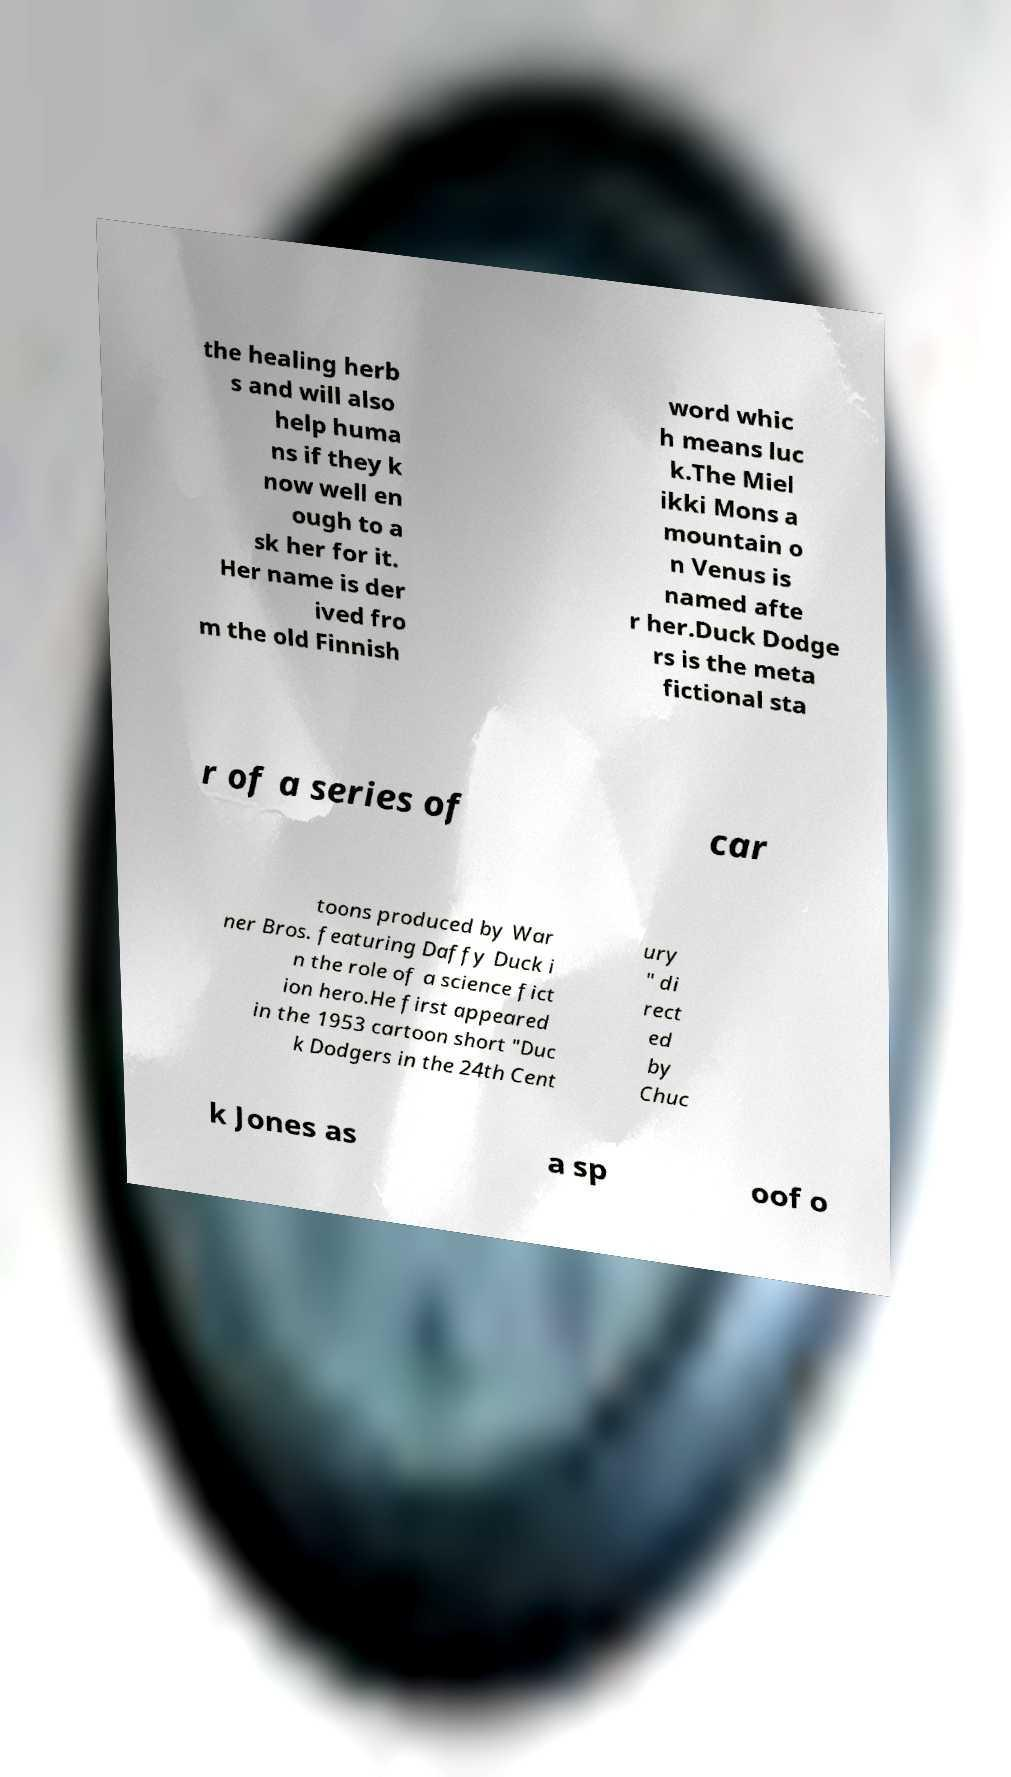Could you extract and type out the text from this image? the healing herb s and will also help huma ns if they k now well en ough to a sk her for it. Her name is der ived fro m the old Finnish word whic h means luc k.The Miel ikki Mons a mountain o n Venus is named afte r her.Duck Dodge rs is the meta fictional sta r of a series of car toons produced by War ner Bros. featuring Daffy Duck i n the role of a science fict ion hero.He first appeared in the 1953 cartoon short "Duc k Dodgers in the 24th Cent ury " di rect ed by Chuc k Jones as a sp oof o 